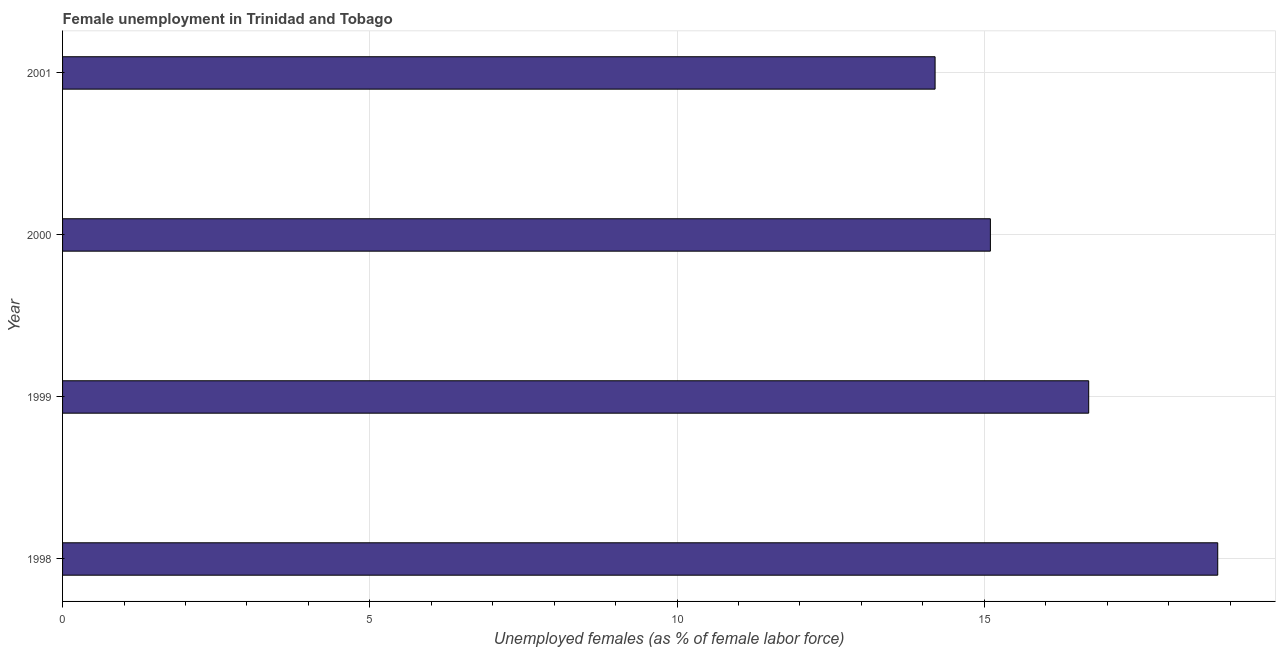Does the graph contain grids?
Your answer should be compact. Yes. What is the title of the graph?
Provide a succinct answer. Female unemployment in Trinidad and Tobago. What is the label or title of the X-axis?
Provide a succinct answer. Unemployed females (as % of female labor force). What is the label or title of the Y-axis?
Ensure brevity in your answer.  Year. What is the unemployed females population in 1999?
Ensure brevity in your answer.  16.7. Across all years, what is the maximum unemployed females population?
Offer a very short reply. 18.8. Across all years, what is the minimum unemployed females population?
Ensure brevity in your answer.  14.2. In which year was the unemployed females population maximum?
Make the answer very short. 1998. What is the sum of the unemployed females population?
Offer a terse response. 64.8. What is the difference between the unemployed females population in 1999 and 2000?
Your answer should be very brief. 1.6. What is the average unemployed females population per year?
Your answer should be very brief. 16.2. What is the median unemployed females population?
Offer a very short reply. 15.9. In how many years, is the unemployed females population greater than 18 %?
Keep it short and to the point. 1. Do a majority of the years between 1999 and 2001 (inclusive) have unemployed females population greater than 14 %?
Provide a succinct answer. Yes. What is the ratio of the unemployed females population in 1998 to that in 2001?
Make the answer very short. 1.32. What is the difference between the highest and the lowest unemployed females population?
Offer a very short reply. 4.6. How many bars are there?
Your response must be concise. 4. What is the difference between two consecutive major ticks on the X-axis?
Give a very brief answer. 5. Are the values on the major ticks of X-axis written in scientific E-notation?
Offer a terse response. No. What is the Unemployed females (as % of female labor force) in 1998?
Your response must be concise. 18.8. What is the Unemployed females (as % of female labor force) in 1999?
Offer a very short reply. 16.7. What is the Unemployed females (as % of female labor force) of 2000?
Offer a very short reply. 15.1. What is the Unemployed females (as % of female labor force) of 2001?
Offer a terse response. 14.2. What is the difference between the Unemployed females (as % of female labor force) in 1998 and 2001?
Keep it short and to the point. 4.6. What is the difference between the Unemployed females (as % of female labor force) in 1999 and 2000?
Give a very brief answer. 1.6. What is the difference between the Unemployed females (as % of female labor force) in 2000 and 2001?
Your answer should be compact. 0.9. What is the ratio of the Unemployed females (as % of female labor force) in 1998 to that in 1999?
Give a very brief answer. 1.13. What is the ratio of the Unemployed females (as % of female labor force) in 1998 to that in 2000?
Your answer should be compact. 1.25. What is the ratio of the Unemployed females (as % of female labor force) in 1998 to that in 2001?
Provide a succinct answer. 1.32. What is the ratio of the Unemployed females (as % of female labor force) in 1999 to that in 2000?
Provide a succinct answer. 1.11. What is the ratio of the Unemployed females (as % of female labor force) in 1999 to that in 2001?
Your answer should be very brief. 1.18. What is the ratio of the Unemployed females (as % of female labor force) in 2000 to that in 2001?
Your answer should be compact. 1.06. 